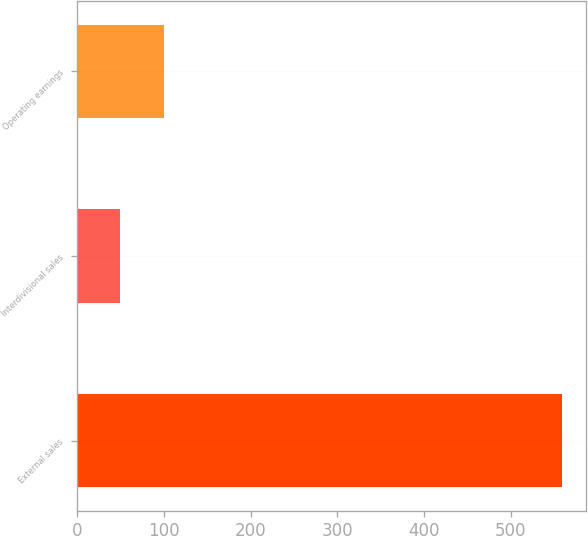<chart> <loc_0><loc_0><loc_500><loc_500><bar_chart><fcel>External sales<fcel>Interdivisional sales<fcel>Operating earnings<nl><fcel>559<fcel>49<fcel>100<nl></chart> 